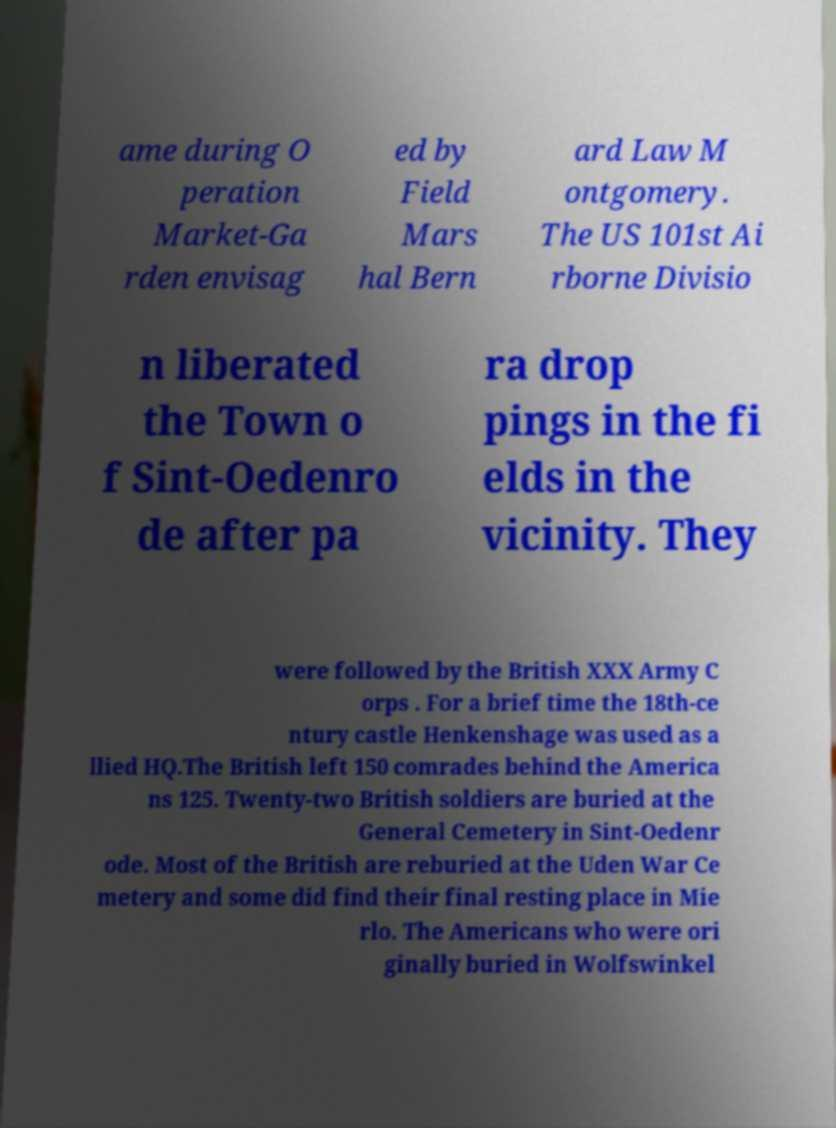There's text embedded in this image that I need extracted. Can you transcribe it verbatim? ame during O peration Market-Ga rden envisag ed by Field Mars hal Bern ard Law M ontgomery. The US 101st Ai rborne Divisio n liberated the Town o f Sint-Oedenro de after pa ra drop pings in the fi elds in the vicinity. They were followed by the British XXX Army C orps . For a brief time the 18th-ce ntury castle Henkenshage was used as a llied HQ.The British left 150 comrades behind the America ns 125. Twenty-two British soldiers are buried at the General Cemetery in Sint-Oedenr ode. Most of the British are reburied at the Uden War Ce metery and some did find their final resting place in Mie rlo. The Americans who were ori ginally buried in Wolfswinkel 